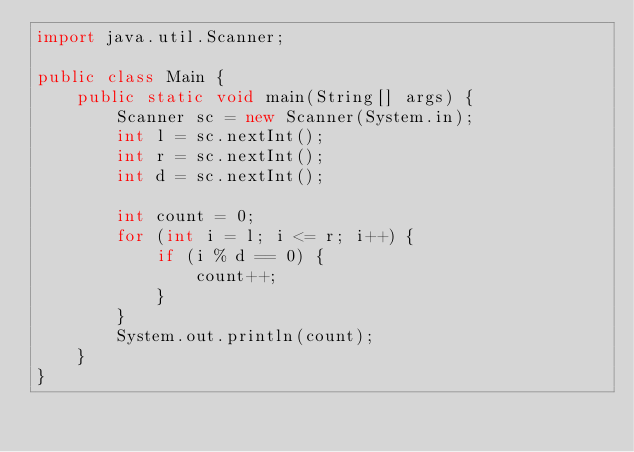Convert code to text. <code><loc_0><loc_0><loc_500><loc_500><_Java_>import java.util.Scanner;

public class Main {
	public static void main(String[] args) {
		Scanner sc = new Scanner(System.in);
		int l = sc.nextInt();
		int r = sc.nextInt();
		int d = sc.nextInt();

		int count = 0;
		for (int i = l; i <= r; i++) {
			if (i % d == 0) {
				count++;
			}
		}
		System.out.println(count);
	}
}
</code> 